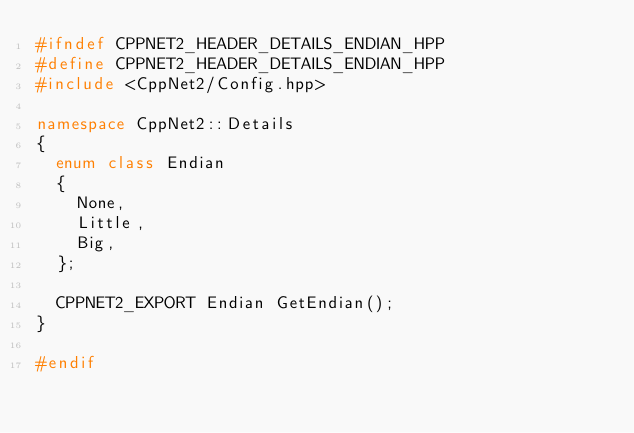Convert code to text. <code><loc_0><loc_0><loc_500><loc_500><_C++_>#ifndef CPPNET2_HEADER_DETAILS_ENDIAN_HPP
#define CPPNET2_HEADER_DETAILS_ENDIAN_HPP
#include <CppNet2/Config.hpp>

namespace CppNet2::Details
{
	enum class Endian
	{
		None,
		Little,
		Big,
	};

	CPPNET2_EXPORT Endian GetEndian();
}

#endif</code> 